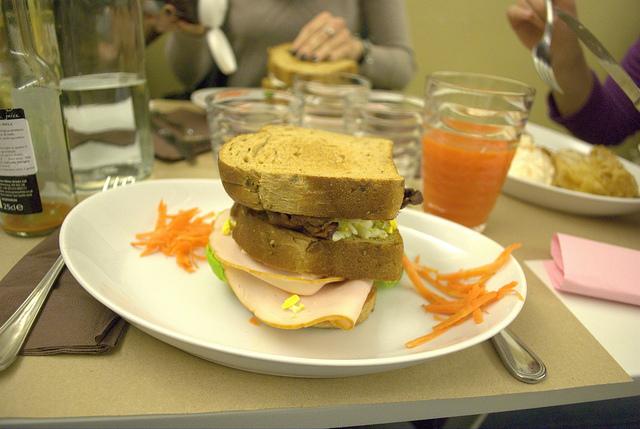What kind of utensil is to the right of the plate closest to the camera?
Concise answer only. Spoon. What color is the drink?
Be succinct. Orange. How many sandwiches are visible in the photo?
Answer briefly. 2. What is in the glass?
Answer briefly. Juice. Is there a sandwich on the plate?
Write a very short answer. Yes. 